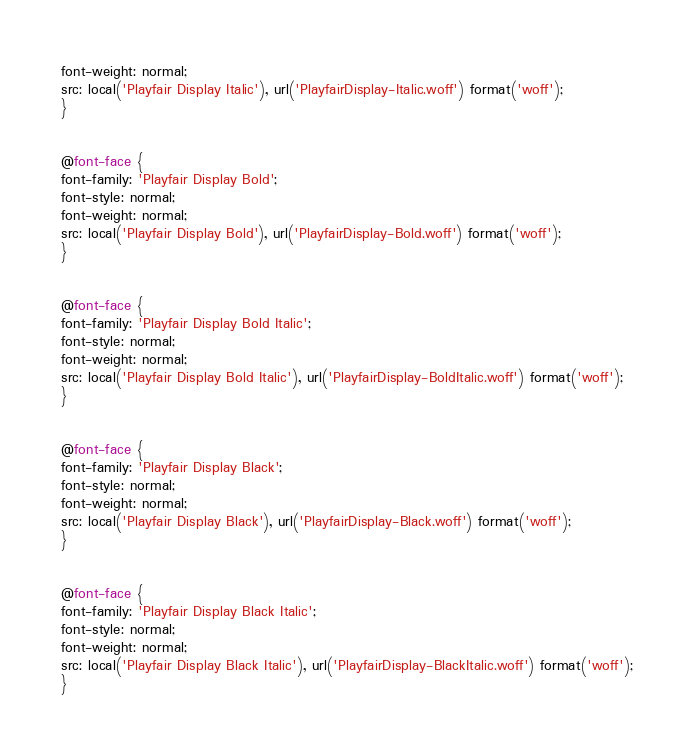<code> <loc_0><loc_0><loc_500><loc_500><_CSS_>font-weight: normal;
src: local('Playfair Display Italic'), url('PlayfairDisplay-Italic.woff') format('woff');
}


@font-face {
font-family: 'Playfair Display Bold';
font-style: normal;
font-weight: normal;
src: local('Playfair Display Bold'), url('PlayfairDisplay-Bold.woff') format('woff');
}


@font-face {
font-family: 'Playfair Display Bold Italic';
font-style: normal;
font-weight: normal;
src: local('Playfair Display Bold Italic'), url('PlayfairDisplay-BoldItalic.woff') format('woff');
}


@font-face {
font-family: 'Playfair Display Black';
font-style: normal;
font-weight: normal;
src: local('Playfair Display Black'), url('PlayfairDisplay-Black.woff') format('woff');
}


@font-face {
font-family: 'Playfair Display Black Italic';
font-style: normal;
font-weight: normal;
src: local('Playfair Display Black Italic'), url('PlayfairDisplay-BlackItalic.woff') format('woff');
}</code> 